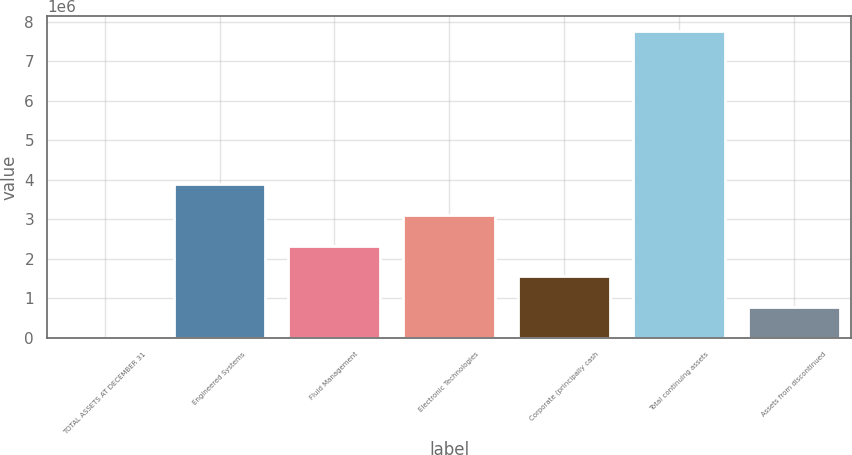<chart> <loc_0><loc_0><loc_500><loc_500><bar_chart><fcel>TOTAL ASSETS AT DECEMBER 31<fcel>Engineered Systems<fcel>Fluid Management<fcel>Electronic Technologies<fcel>Corporate (principally cash<fcel>Total continuing assets<fcel>Assets from discontinued<nl><fcel>2009<fcel>3.88386e+06<fcel>2.33112e+06<fcel>3.10749e+06<fcel>1.55475e+06<fcel>7.7657e+06<fcel>778378<nl></chart> 